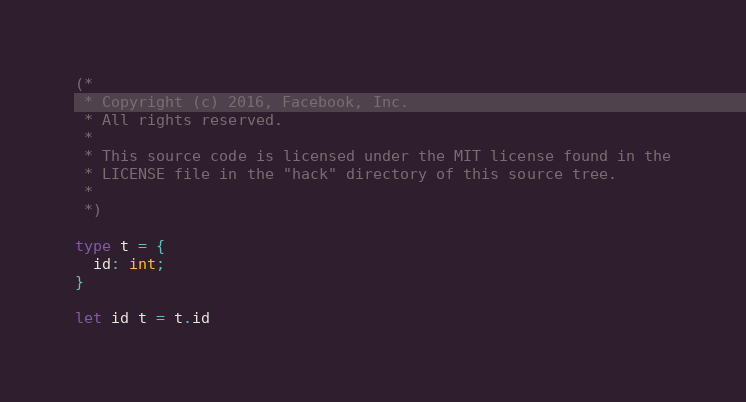<code> <loc_0><loc_0><loc_500><loc_500><_OCaml_>(*
 * Copyright (c) 2016, Facebook, Inc.
 * All rights reserved.
 *
 * This source code is licensed under the MIT license found in the
 * LICENSE file in the "hack" directory of this source tree.
 *
 *)

type t = {
  id: int;
}

let id t = t.id
</code> 